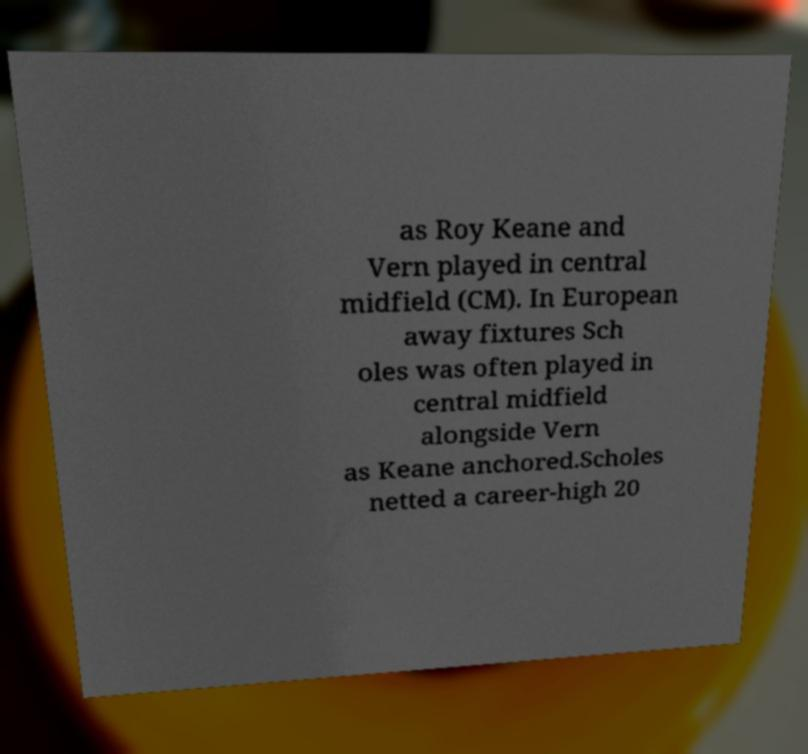Can you accurately transcribe the text from the provided image for me? as Roy Keane and Vern played in central midfield (CM). In European away fixtures Sch oles was often played in central midfield alongside Vern as Keane anchored.Scholes netted a career-high 20 